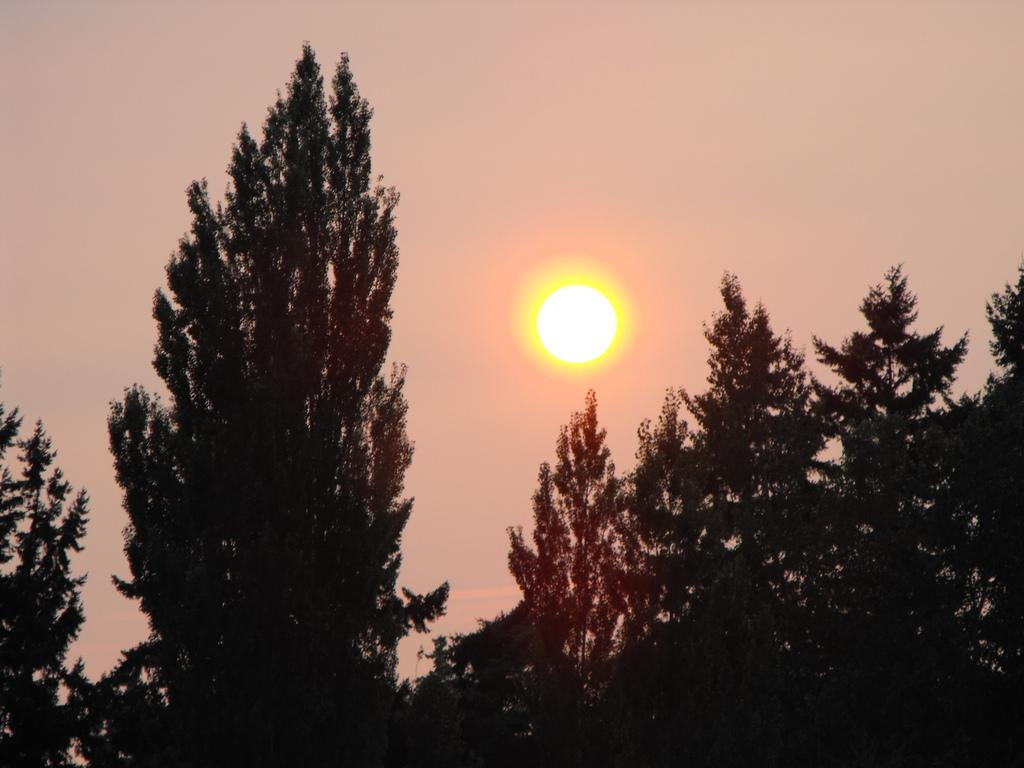What type of vegetation can be seen in the image? There are trees in the image. What celestial body is visible in the background of the image? The sun is visible in the background of the image. What else can be seen in the background of the image? The sky is visible in the background of the image. What type of art is displayed on the trees in the image? There is no art displayed on the trees in the image; it features natural vegetation. 